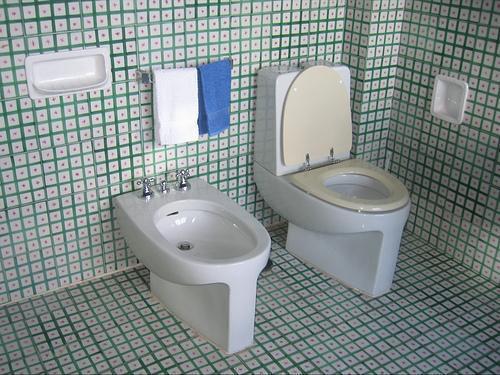How many toilets are in the photo?
Give a very brief answer. 2. 